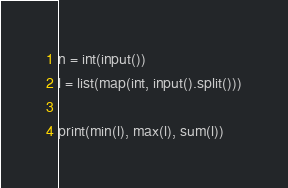<code> <loc_0><loc_0><loc_500><loc_500><_Python_>n = int(input())
l = list(map(int, input().split()))

print(min(l), max(l), sum(l))</code> 